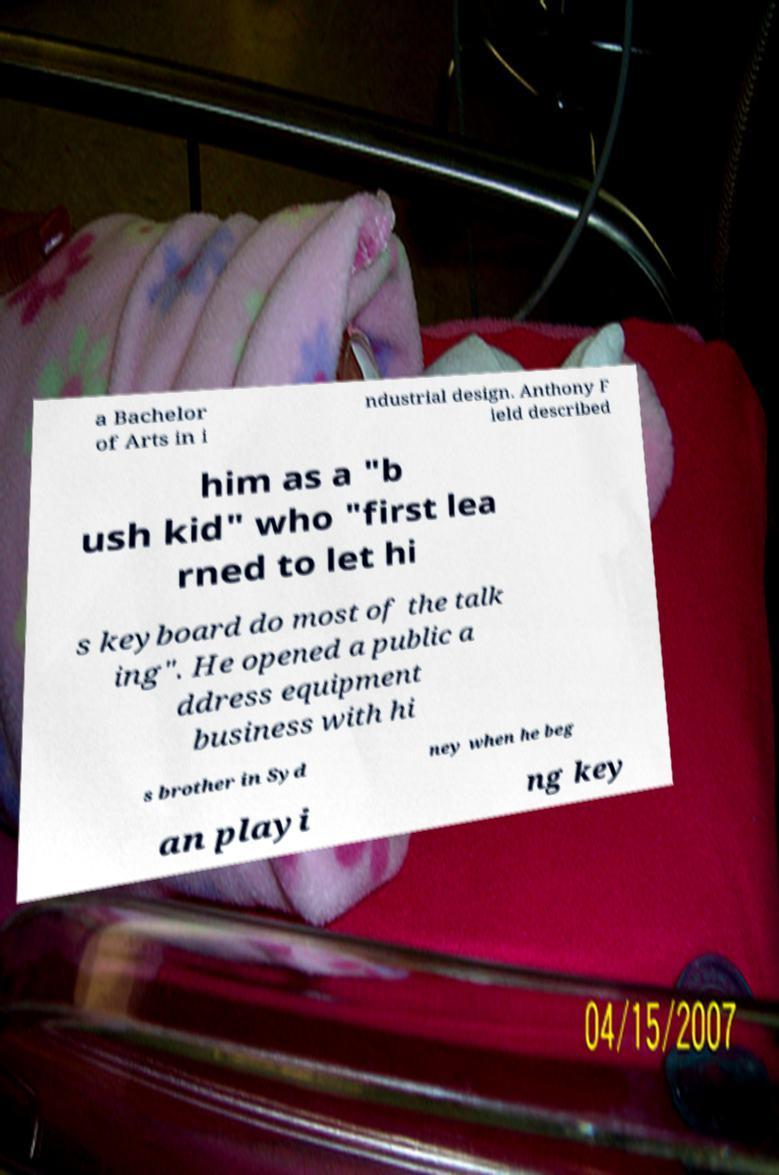Can you accurately transcribe the text from the provided image for me? a Bachelor of Arts in i ndustrial design. Anthony F ield described him as a "b ush kid" who "first lea rned to let hi s keyboard do most of the talk ing". He opened a public a ddress equipment business with hi s brother in Syd ney when he beg an playi ng key 